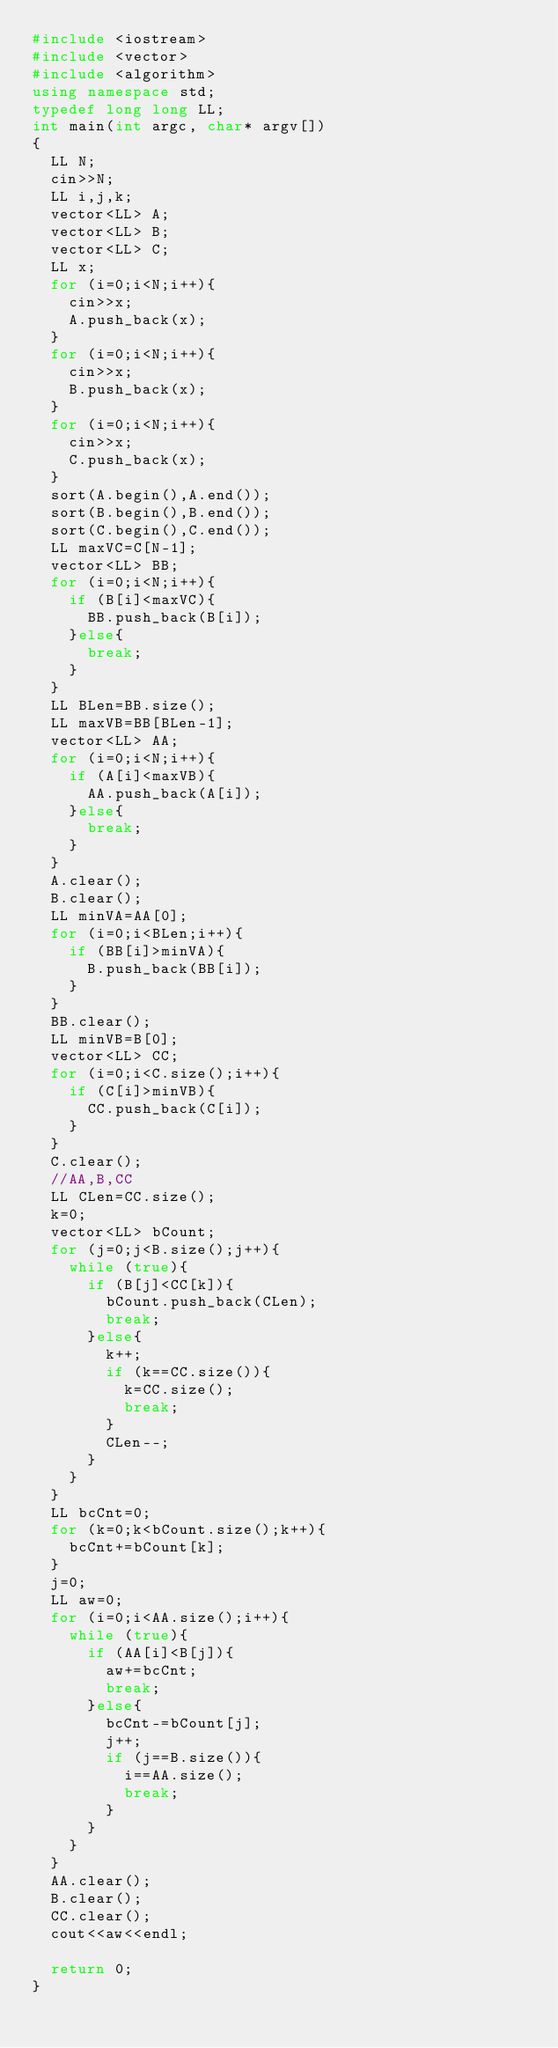<code> <loc_0><loc_0><loc_500><loc_500><_C++_>#include <iostream>
#include <vector>
#include <algorithm>
using namespace std;
typedef long long LL;
int main(int argc, char* argv[])
{
	LL N;
	cin>>N;
	LL i,j,k;
	vector<LL> A;
	vector<LL> B;
	vector<LL> C;
	LL x;
	for (i=0;i<N;i++){
		cin>>x;
		A.push_back(x);
	}
	for (i=0;i<N;i++){
		cin>>x;
		B.push_back(x);
	}
	for (i=0;i<N;i++){
		cin>>x;
		C.push_back(x);
	}
	sort(A.begin(),A.end());
	sort(B.begin(),B.end());
	sort(C.begin(),C.end());
	LL maxVC=C[N-1];
	vector<LL> BB;
	for (i=0;i<N;i++){
		if (B[i]<maxVC){
			BB.push_back(B[i]);
		}else{
			break;
		}
	}
	LL BLen=BB.size();
	LL maxVB=BB[BLen-1];
	vector<LL> AA;	
	for (i=0;i<N;i++){
		if (A[i]<maxVB){
			AA.push_back(A[i]);
		}else{
			break;
		}
	}
	A.clear();
	B.clear();
	LL minVA=AA[0];
	for (i=0;i<BLen;i++){
		if (BB[i]>minVA){
			B.push_back(BB[i]);
		}
	}
	BB.clear();
	LL minVB=B[0];
	vector<LL> CC;	
	for (i=0;i<C.size();i++){
		if (C[i]>minVB){
			CC.push_back(C[i]);
		}
	}
	C.clear();
	//AA,B,CC
	LL CLen=CC.size();
	k=0;
	vector<LL> bCount;
	for (j=0;j<B.size();j++){
		while (true){
			if (B[j]<CC[k]){
				bCount.push_back(CLen);
				break;
			}else{
				k++;
				if (k==CC.size()){
					k=CC.size();
					break;
				}
				CLen--;
			}
		}
	}
	LL bcCnt=0;
	for (k=0;k<bCount.size();k++){
		bcCnt+=bCount[k];
	}
	j=0;
	LL aw=0;
	for (i=0;i<AA.size();i++){
		while (true){
			if (AA[i]<B[j]){
				aw+=bcCnt;
				break;
			}else{
				bcCnt-=bCount[j];
				j++;
				if (j==B.size()){
					i==AA.size();
					break;
				}
			}
		}
	}
	AA.clear();
	B.clear();
	CC.clear();
	cout<<aw<<endl;
	
	return 0;
}</code> 